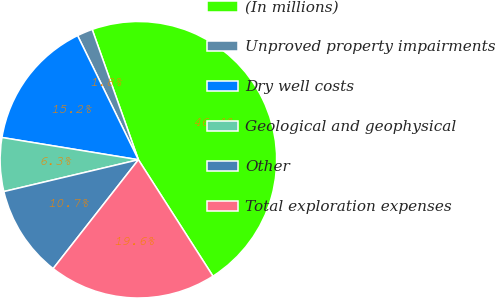Convert chart to OTSL. <chart><loc_0><loc_0><loc_500><loc_500><pie_chart><fcel>(In millions)<fcel>Unproved property impairments<fcel>Dry well costs<fcel>Geological and geophysical<fcel>Other<fcel>Total exploration expenses<nl><fcel>46.36%<fcel>1.82%<fcel>15.18%<fcel>6.27%<fcel>10.73%<fcel>19.64%<nl></chart> 